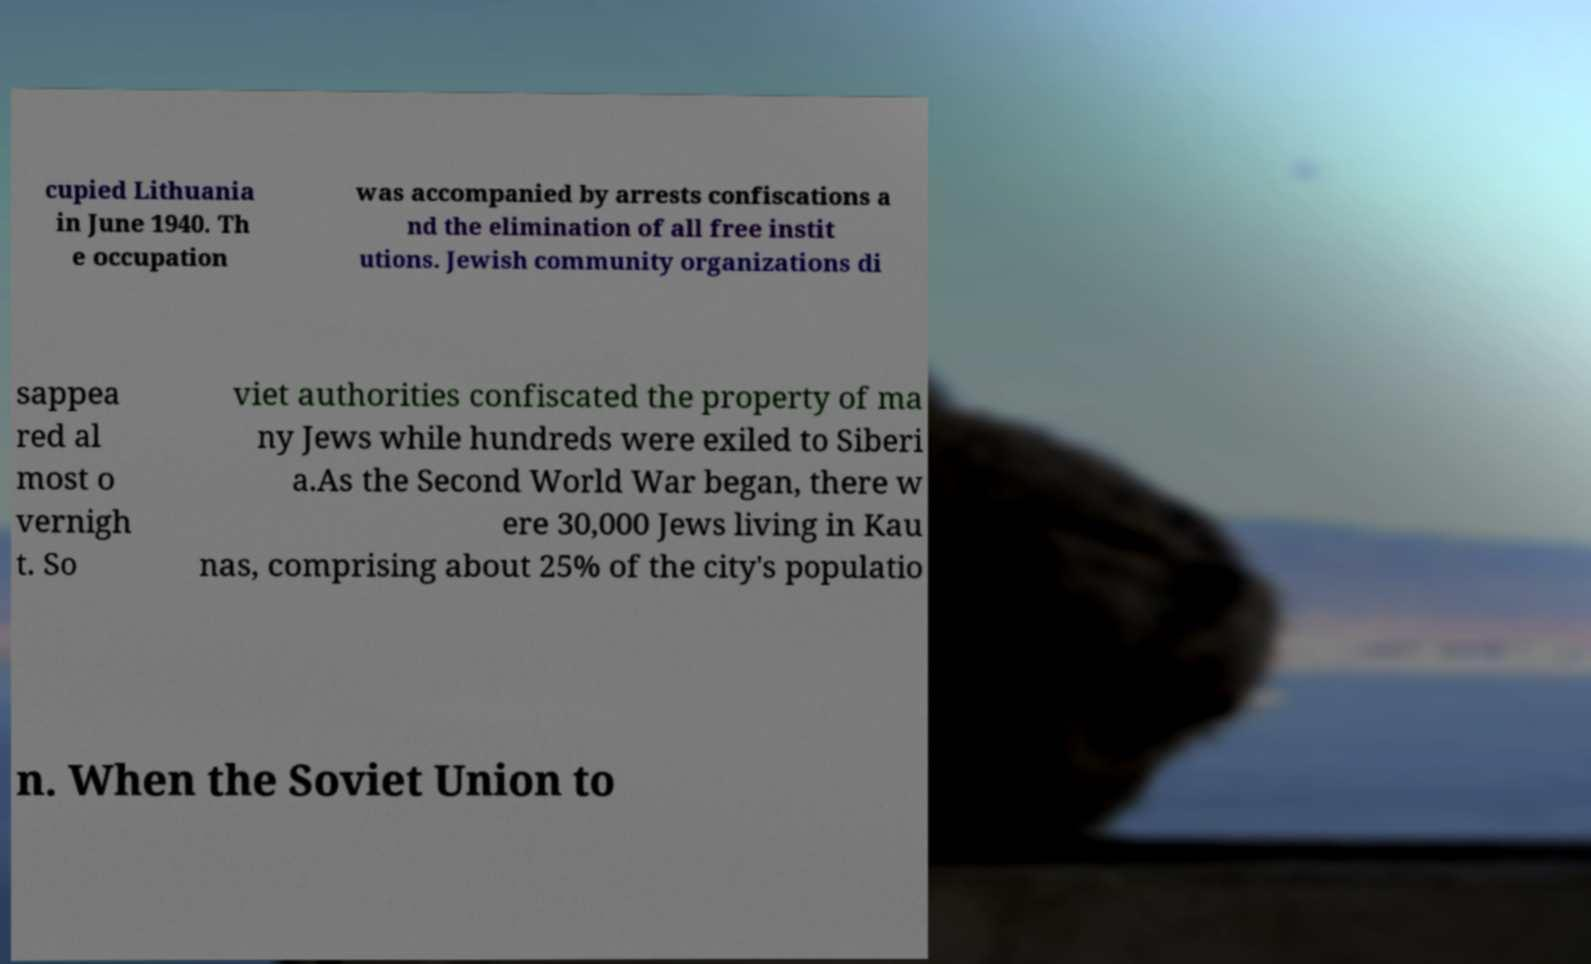Could you assist in decoding the text presented in this image and type it out clearly? cupied Lithuania in June 1940. Th e occupation was accompanied by arrests confiscations a nd the elimination of all free instit utions. Jewish community organizations di sappea red al most o vernigh t. So viet authorities confiscated the property of ma ny Jews while hundreds were exiled to Siberi a.As the Second World War began, there w ere 30,000 Jews living in Kau nas, comprising about 25% of the city's populatio n. When the Soviet Union to 